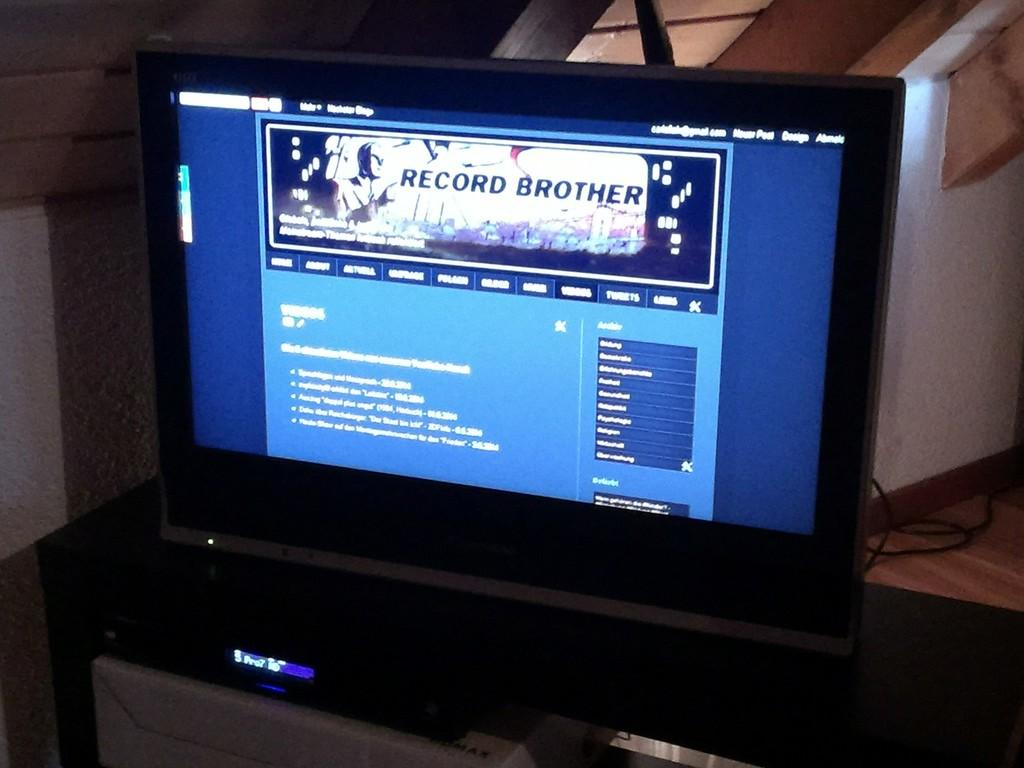<image>
Relay a brief, clear account of the picture shown. a computer is opened to a page called Record Brother 